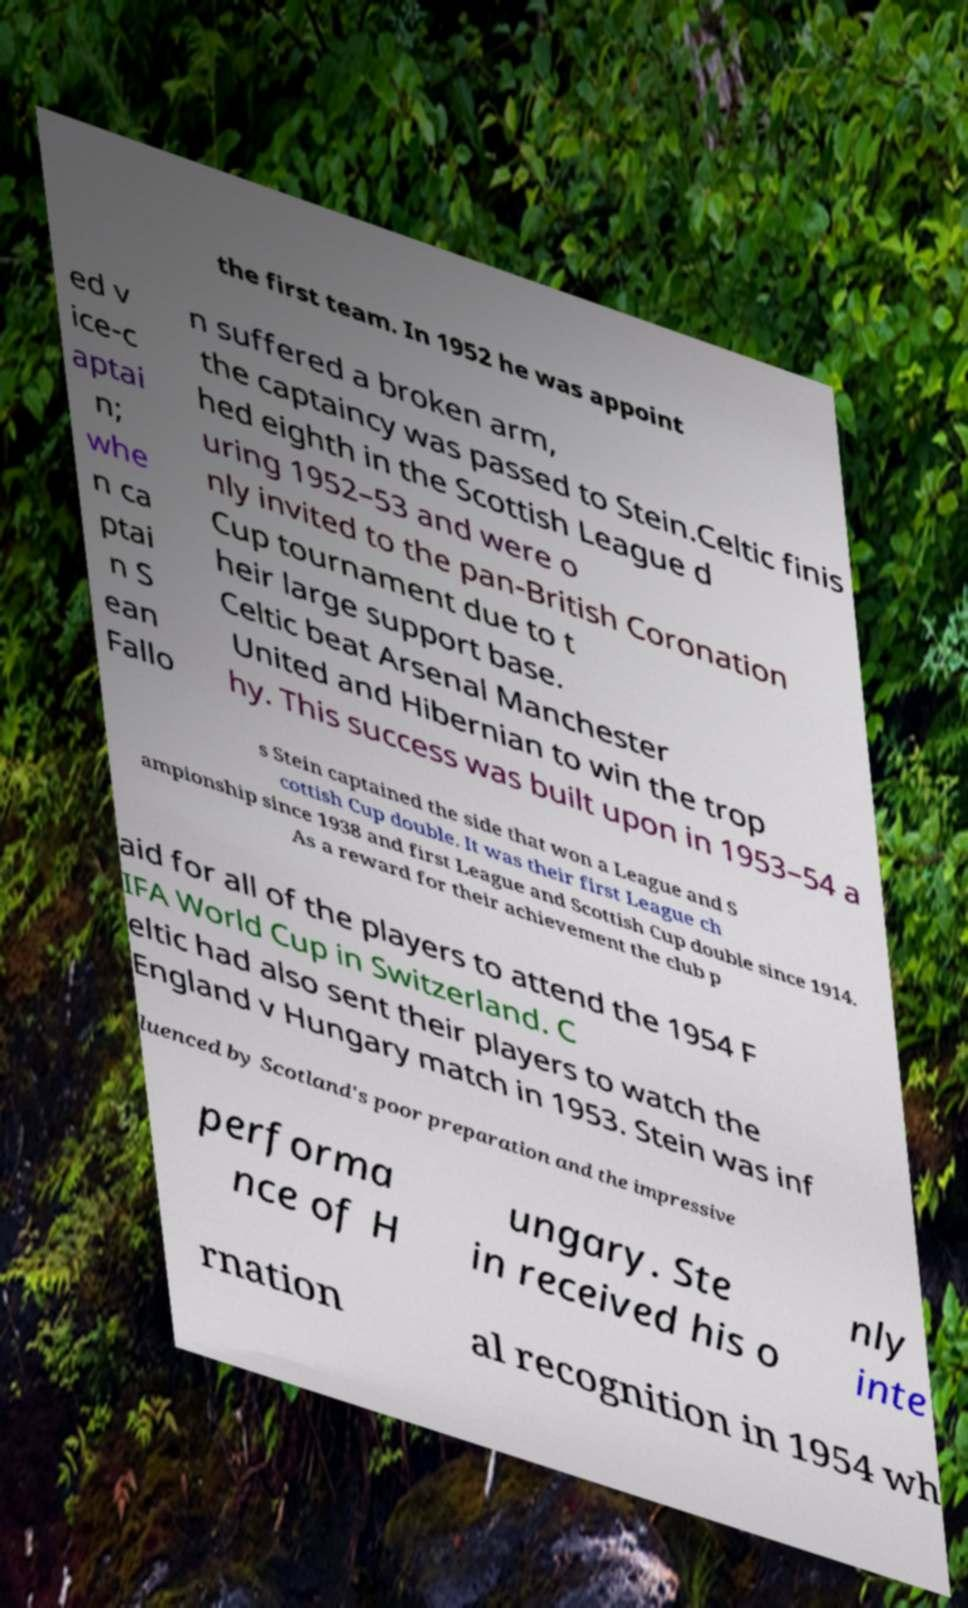Can you accurately transcribe the text from the provided image for me? the first team. In 1952 he was appoint ed v ice-c aptai n; whe n ca ptai n S ean Fallo n suffered a broken arm, the captaincy was passed to Stein.Celtic finis hed eighth in the Scottish League d uring 1952–53 and were o nly invited to the pan-British Coronation Cup tournament due to t heir large support base. Celtic beat Arsenal Manchester United and Hibernian to win the trop hy. This success was built upon in 1953–54 a s Stein captained the side that won a League and S cottish Cup double. It was their first League ch ampionship since 1938 and first League and Scottish Cup double since 1914. As a reward for their achievement the club p aid for all of the players to attend the 1954 F IFA World Cup in Switzerland. C eltic had also sent their players to watch the England v Hungary match in 1953. Stein was inf luenced by Scotland's poor preparation and the impressive performa nce of H ungary. Ste in received his o nly inte rnation al recognition in 1954 wh 